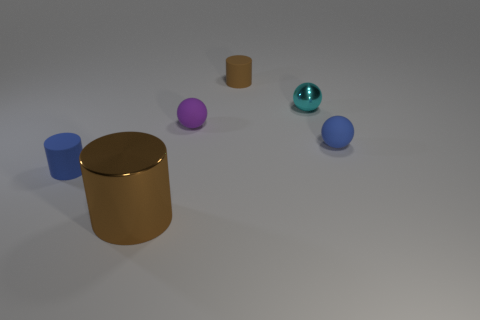There is a tiny blue thing to the right of the brown matte thing; are there any blue balls to the left of it? While there is indeed a small blue object to the right of the large brown cylinder, there are no blue balls to its left. The only blue object on that side is a blue cylinder, and there's a spherical object further away, but it is teal in color, not blue. 